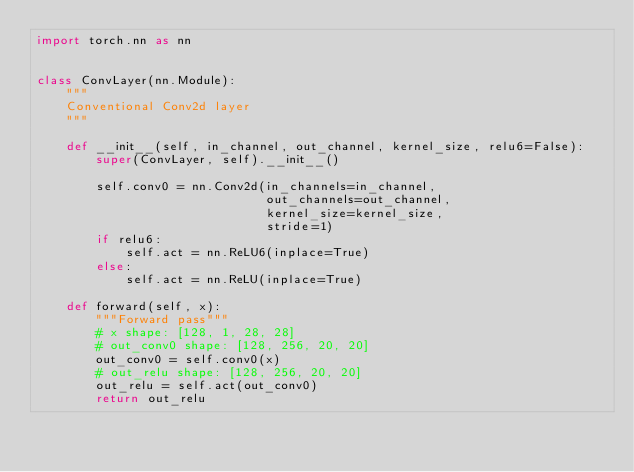Convert code to text. <code><loc_0><loc_0><loc_500><loc_500><_Python_>import torch.nn as nn


class ConvLayer(nn.Module):
    """
    Conventional Conv2d layer
    """

    def __init__(self, in_channel, out_channel, kernel_size, relu6=False):
        super(ConvLayer, self).__init__()

        self.conv0 = nn.Conv2d(in_channels=in_channel,
                               out_channels=out_channel,
                               kernel_size=kernel_size,
                               stride=1)
        if relu6:
            self.act = nn.ReLU6(inplace=True)
        else:
            self.act = nn.ReLU(inplace=True)

    def forward(self, x):
        """Forward pass"""
        # x shape: [128, 1, 28, 28]
        # out_conv0 shape: [128, 256, 20, 20]
        out_conv0 = self.conv0(x)
        # out_relu shape: [128, 256, 20, 20]
        out_relu = self.act(out_conv0)
        return out_relu
</code> 